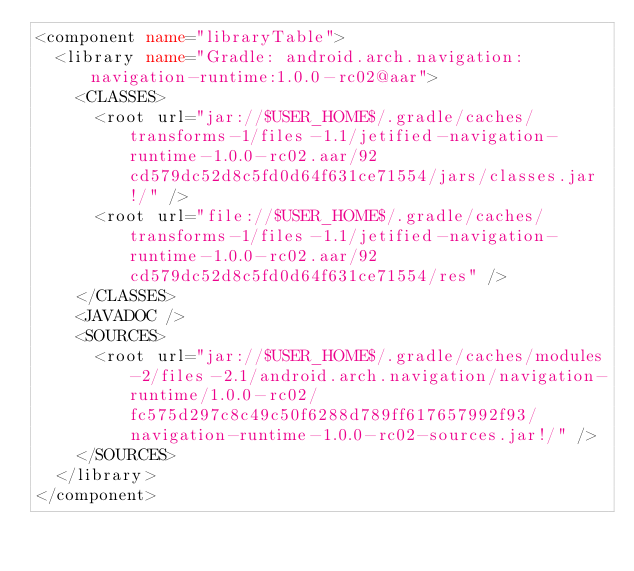<code> <loc_0><loc_0><loc_500><loc_500><_XML_><component name="libraryTable">
  <library name="Gradle: android.arch.navigation:navigation-runtime:1.0.0-rc02@aar">
    <CLASSES>
      <root url="jar://$USER_HOME$/.gradle/caches/transforms-1/files-1.1/jetified-navigation-runtime-1.0.0-rc02.aar/92cd579dc52d8c5fd0d64f631ce71554/jars/classes.jar!/" />
      <root url="file://$USER_HOME$/.gradle/caches/transforms-1/files-1.1/jetified-navigation-runtime-1.0.0-rc02.aar/92cd579dc52d8c5fd0d64f631ce71554/res" />
    </CLASSES>
    <JAVADOC />
    <SOURCES>
      <root url="jar://$USER_HOME$/.gradle/caches/modules-2/files-2.1/android.arch.navigation/navigation-runtime/1.0.0-rc02/fc575d297c8c49c50f6288d789ff617657992f93/navigation-runtime-1.0.0-rc02-sources.jar!/" />
    </SOURCES>
  </library>
</component></code> 